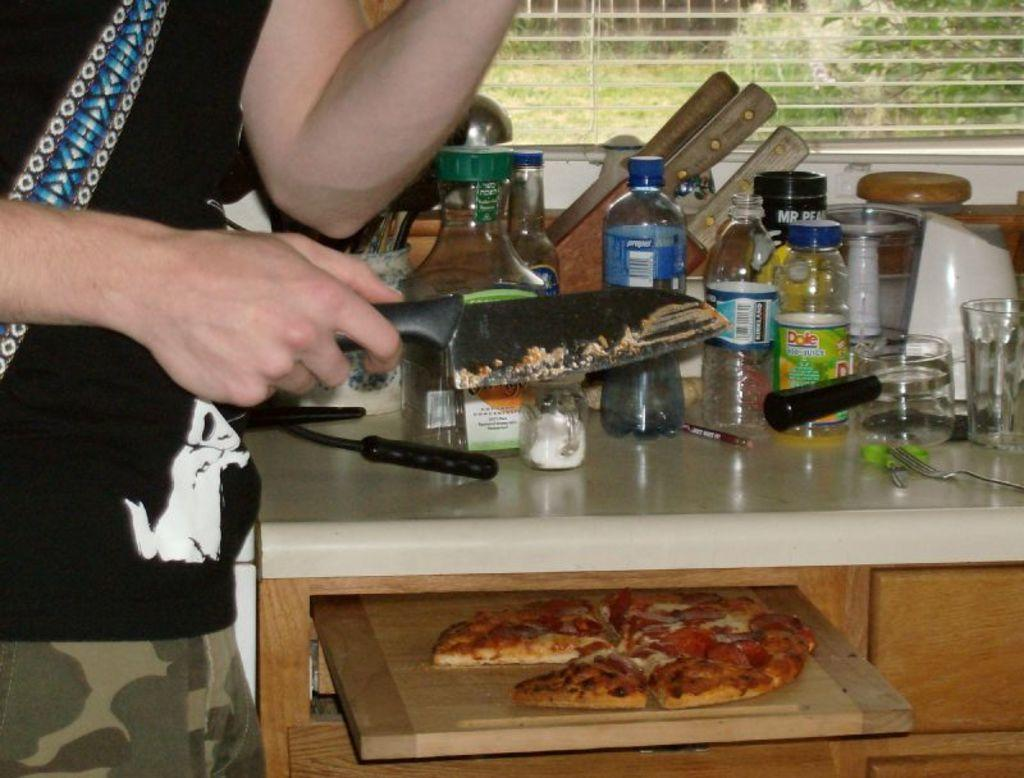<image>
Provide a brief description of the given image. The pizza was sliced with a kitchen knife by the young man. 